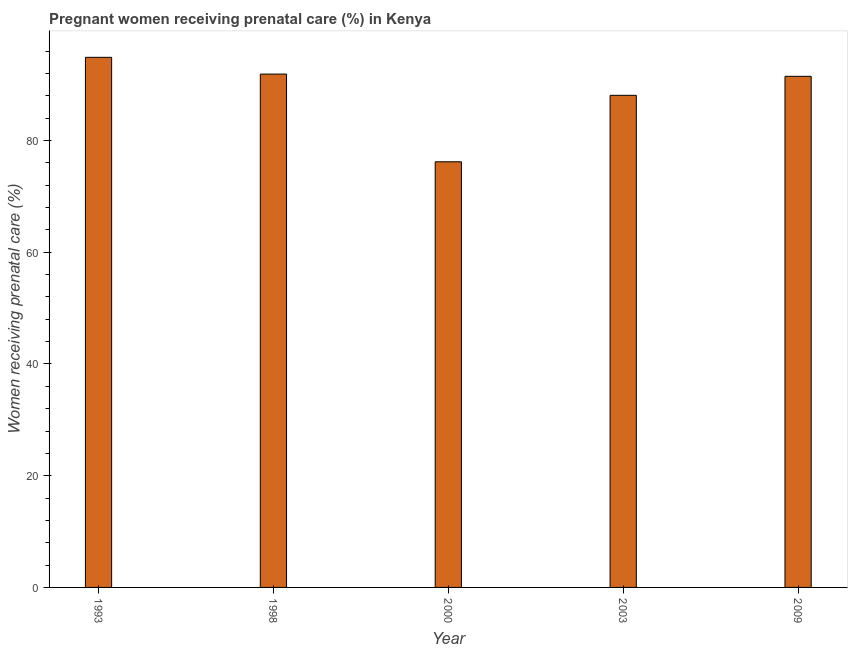Does the graph contain grids?
Ensure brevity in your answer.  No. What is the title of the graph?
Provide a short and direct response. Pregnant women receiving prenatal care (%) in Kenya. What is the label or title of the Y-axis?
Your answer should be compact. Women receiving prenatal care (%). What is the percentage of pregnant women receiving prenatal care in 1998?
Keep it short and to the point. 91.9. Across all years, what is the maximum percentage of pregnant women receiving prenatal care?
Your response must be concise. 94.9. Across all years, what is the minimum percentage of pregnant women receiving prenatal care?
Your answer should be compact. 76.2. In which year was the percentage of pregnant women receiving prenatal care minimum?
Keep it short and to the point. 2000. What is the sum of the percentage of pregnant women receiving prenatal care?
Provide a short and direct response. 442.6. What is the average percentage of pregnant women receiving prenatal care per year?
Your response must be concise. 88.52. What is the median percentage of pregnant women receiving prenatal care?
Your response must be concise. 91.5. In how many years, is the percentage of pregnant women receiving prenatal care greater than 68 %?
Offer a terse response. 5. Do a majority of the years between 1998 and 2003 (inclusive) have percentage of pregnant women receiving prenatal care greater than 28 %?
Make the answer very short. Yes. What is the ratio of the percentage of pregnant women receiving prenatal care in 2000 to that in 2003?
Provide a short and direct response. 0.86. Is the percentage of pregnant women receiving prenatal care in 1998 less than that in 2009?
Offer a terse response. No. Is the difference between the percentage of pregnant women receiving prenatal care in 1998 and 2009 greater than the difference between any two years?
Your answer should be compact. No. Is the sum of the percentage of pregnant women receiving prenatal care in 1998 and 2003 greater than the maximum percentage of pregnant women receiving prenatal care across all years?
Provide a short and direct response. Yes. How many bars are there?
Offer a very short reply. 5. Are all the bars in the graph horizontal?
Your answer should be compact. No. What is the difference between two consecutive major ticks on the Y-axis?
Your answer should be compact. 20. Are the values on the major ticks of Y-axis written in scientific E-notation?
Your response must be concise. No. What is the Women receiving prenatal care (%) in 1993?
Offer a very short reply. 94.9. What is the Women receiving prenatal care (%) in 1998?
Ensure brevity in your answer.  91.9. What is the Women receiving prenatal care (%) of 2000?
Your response must be concise. 76.2. What is the Women receiving prenatal care (%) in 2003?
Keep it short and to the point. 88.1. What is the Women receiving prenatal care (%) of 2009?
Offer a terse response. 91.5. What is the difference between the Women receiving prenatal care (%) in 1993 and 1998?
Give a very brief answer. 3. What is the difference between the Women receiving prenatal care (%) in 1993 and 2000?
Keep it short and to the point. 18.7. What is the difference between the Women receiving prenatal care (%) in 1993 and 2003?
Make the answer very short. 6.8. What is the difference between the Women receiving prenatal care (%) in 1993 and 2009?
Make the answer very short. 3.4. What is the difference between the Women receiving prenatal care (%) in 1998 and 2000?
Give a very brief answer. 15.7. What is the difference between the Women receiving prenatal care (%) in 1998 and 2003?
Your response must be concise. 3.8. What is the difference between the Women receiving prenatal care (%) in 2000 and 2003?
Give a very brief answer. -11.9. What is the difference between the Women receiving prenatal care (%) in 2000 and 2009?
Your response must be concise. -15.3. What is the difference between the Women receiving prenatal care (%) in 2003 and 2009?
Your answer should be compact. -3.4. What is the ratio of the Women receiving prenatal care (%) in 1993 to that in 1998?
Your answer should be very brief. 1.03. What is the ratio of the Women receiving prenatal care (%) in 1993 to that in 2000?
Ensure brevity in your answer.  1.25. What is the ratio of the Women receiving prenatal care (%) in 1993 to that in 2003?
Ensure brevity in your answer.  1.08. What is the ratio of the Women receiving prenatal care (%) in 1998 to that in 2000?
Your answer should be very brief. 1.21. What is the ratio of the Women receiving prenatal care (%) in 1998 to that in 2003?
Give a very brief answer. 1.04. What is the ratio of the Women receiving prenatal care (%) in 2000 to that in 2003?
Your response must be concise. 0.86. What is the ratio of the Women receiving prenatal care (%) in 2000 to that in 2009?
Offer a very short reply. 0.83. What is the ratio of the Women receiving prenatal care (%) in 2003 to that in 2009?
Offer a terse response. 0.96. 